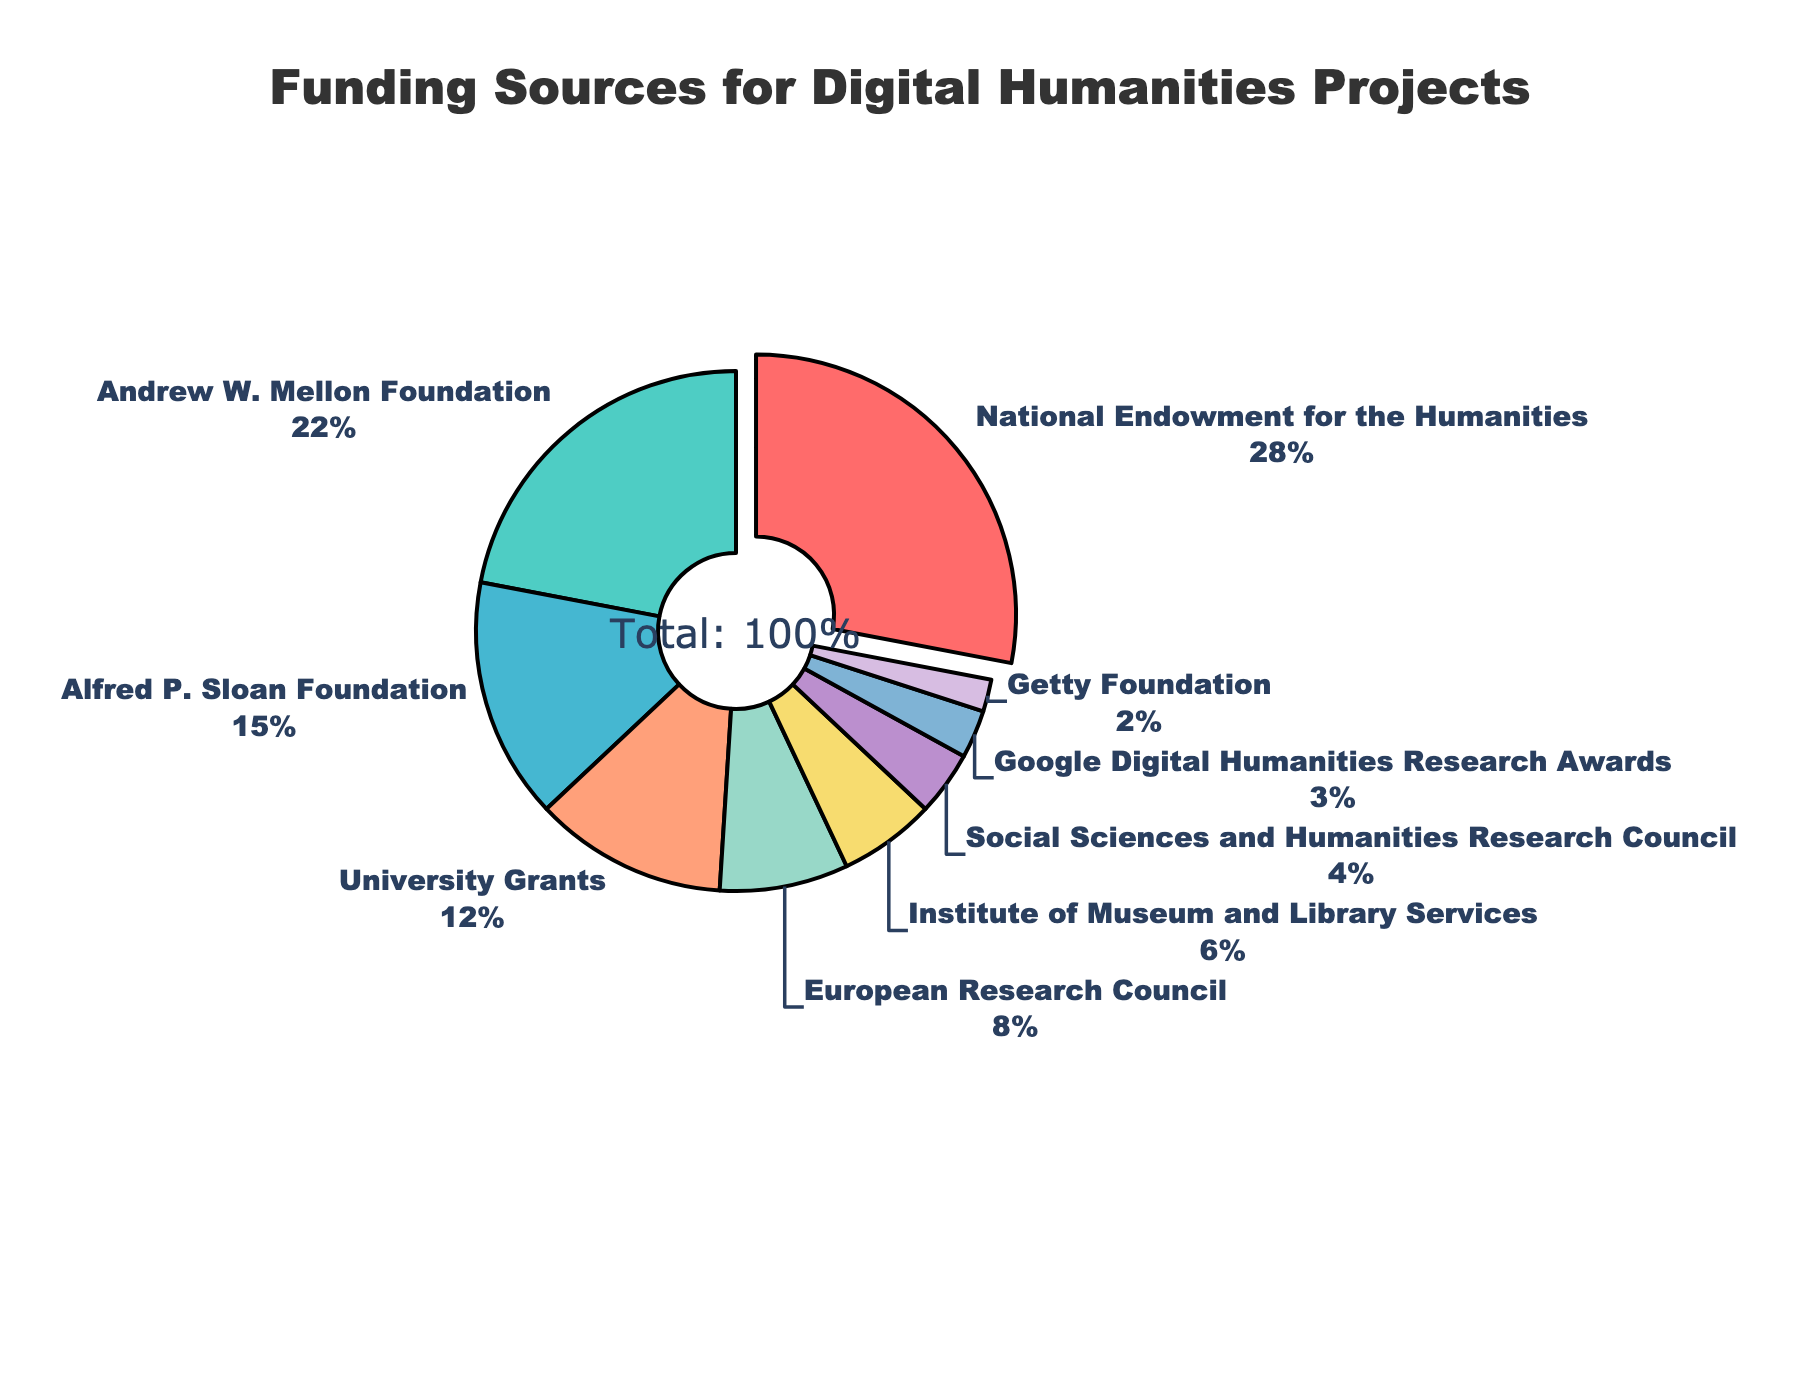what percentage of the funding comes from the National Endowment for the Humanities? Locate the slice of the pie chart labeled "National Endowment for the Humanities." According to the figure, it provides 28% of the funding.
Answer: 28% which organization has the second-largest funding contribution? Determine the organization with the second-largest percentage. The Andrew W. Mellon Foundation contributes 22%, which is the second largest percentage.
Answer: Andrew W. Mellon Foundation compare the funding percentages of the European Research Council and University Grants. Which one is higher? Identify the slices representing the European Research Council and University Grants. The European Research Council has 8% while University Grants has 12%, so University Grants is higher.
Answer: University Grants what is the total percentage of funding provided by the Alfred P. Sloan Foundation and the Institute of Museum and Library Services? Locate the slices for both organizations. The Alfred P. Sloan Foundation provides 15% and the Institute of Museum and Library Services provides 6%. Adding these together: 15% + 6% = 21%.
Answer: 21% Which funding source has the smallest contribution and what percentage does it represent? Identify the slice with the smallest size which is labeled "Getty Foundation." According to the figure, it represents 2%.
Answer: Getty Foundation, 2% what colors represent the National Endowment for the Humanities and the Google Digital Humanities Research Awards respectively in the pie chart? Check the colors associated with the "National Endowment for the Humanities" slice, which is red, and "Google Digital Humanities Research Awards" slice, which is blue.
Answer: Red for National Endowment for the Humanities, blue for Google Digital Humanities Research Awards How much more percentage does the Andrew W. Mellon Foundation provide compared to the Social Sciences and Humanities Research Council? Calculate the difference between the Andrew W. Mellon Foundation's 22% and the Social Sciences and Humanities Research Council's 4%. The difference is 22% - 4% = 18%.
Answer: 18% What is the combined contribution of the Social Sciences and Humanities Research Council and Google Digital Humanities Research Awards? Add the percentages of the Social Sciences and Humanities Research Council (4%) and Google Digital Humanities Research Awards (3%): 4% + 3% = 7%.
Answer: 7% What visual attribute is unique for the slice representing the National Endowment for the Humanities compared to other slices? The slice for the National Endowment for the Humanities is pulled out slightly from the pie chart, distinguishing it from the other slices which are not pulled out.
Answer: Pulled out slice 